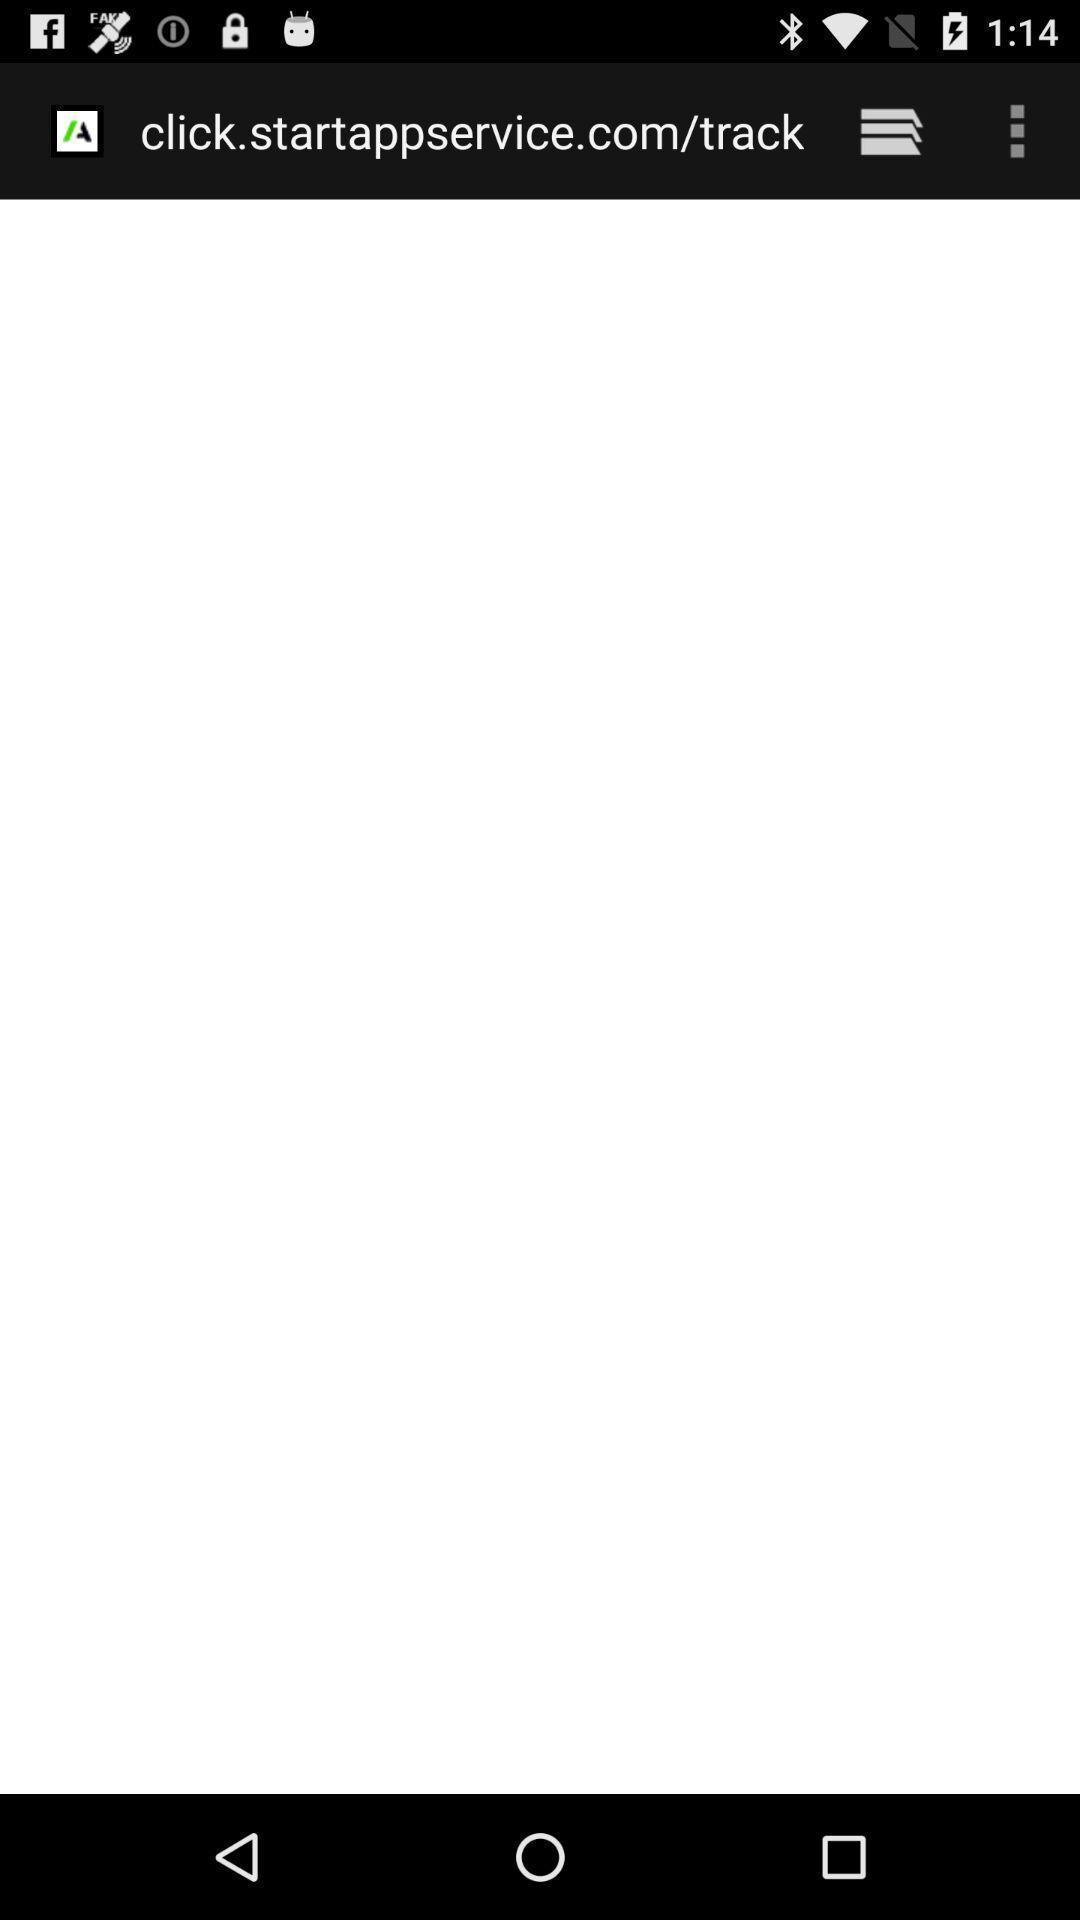Describe the visual elements of this screenshot. Website blank page showing. 